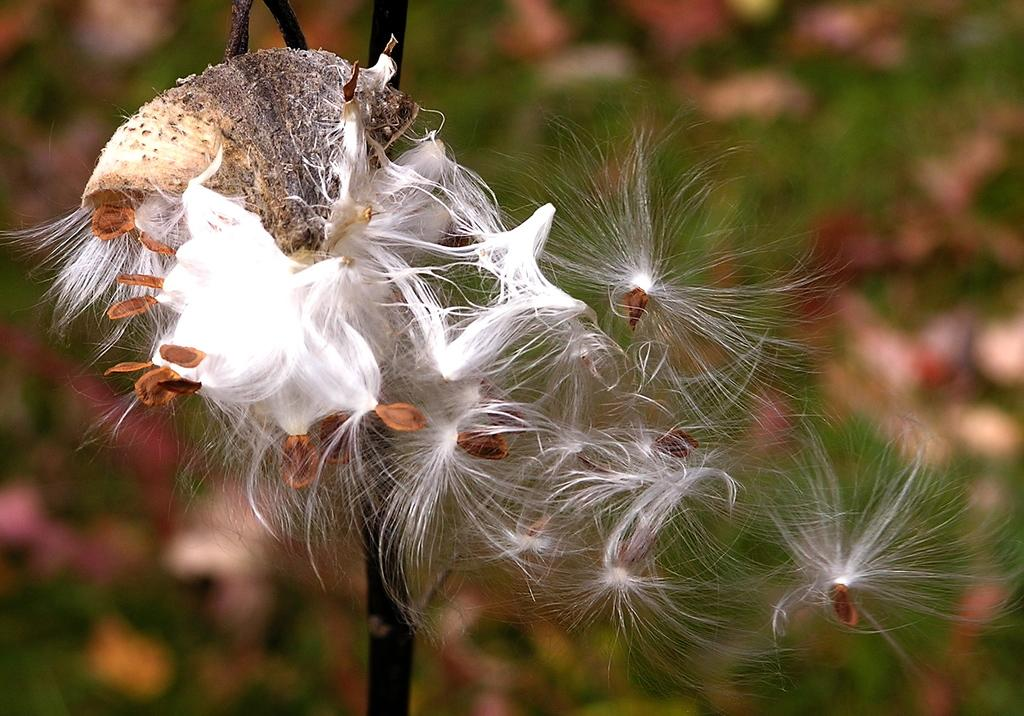What can be seen in the image related to plant reproduction? There are seeds and thin hair-like structures associated with the seeds in the image, which suggests seed dispersal. What part of the plant is visible in the image? There is a stem visible in the image. How is the background of the image depicted? The background of the image is blurry. What role does the father play in the seed dispersal process depicted in the image? There is no father or any human involvement in the seed dispersal process depicted in the image; it is a natural process involving plants. 